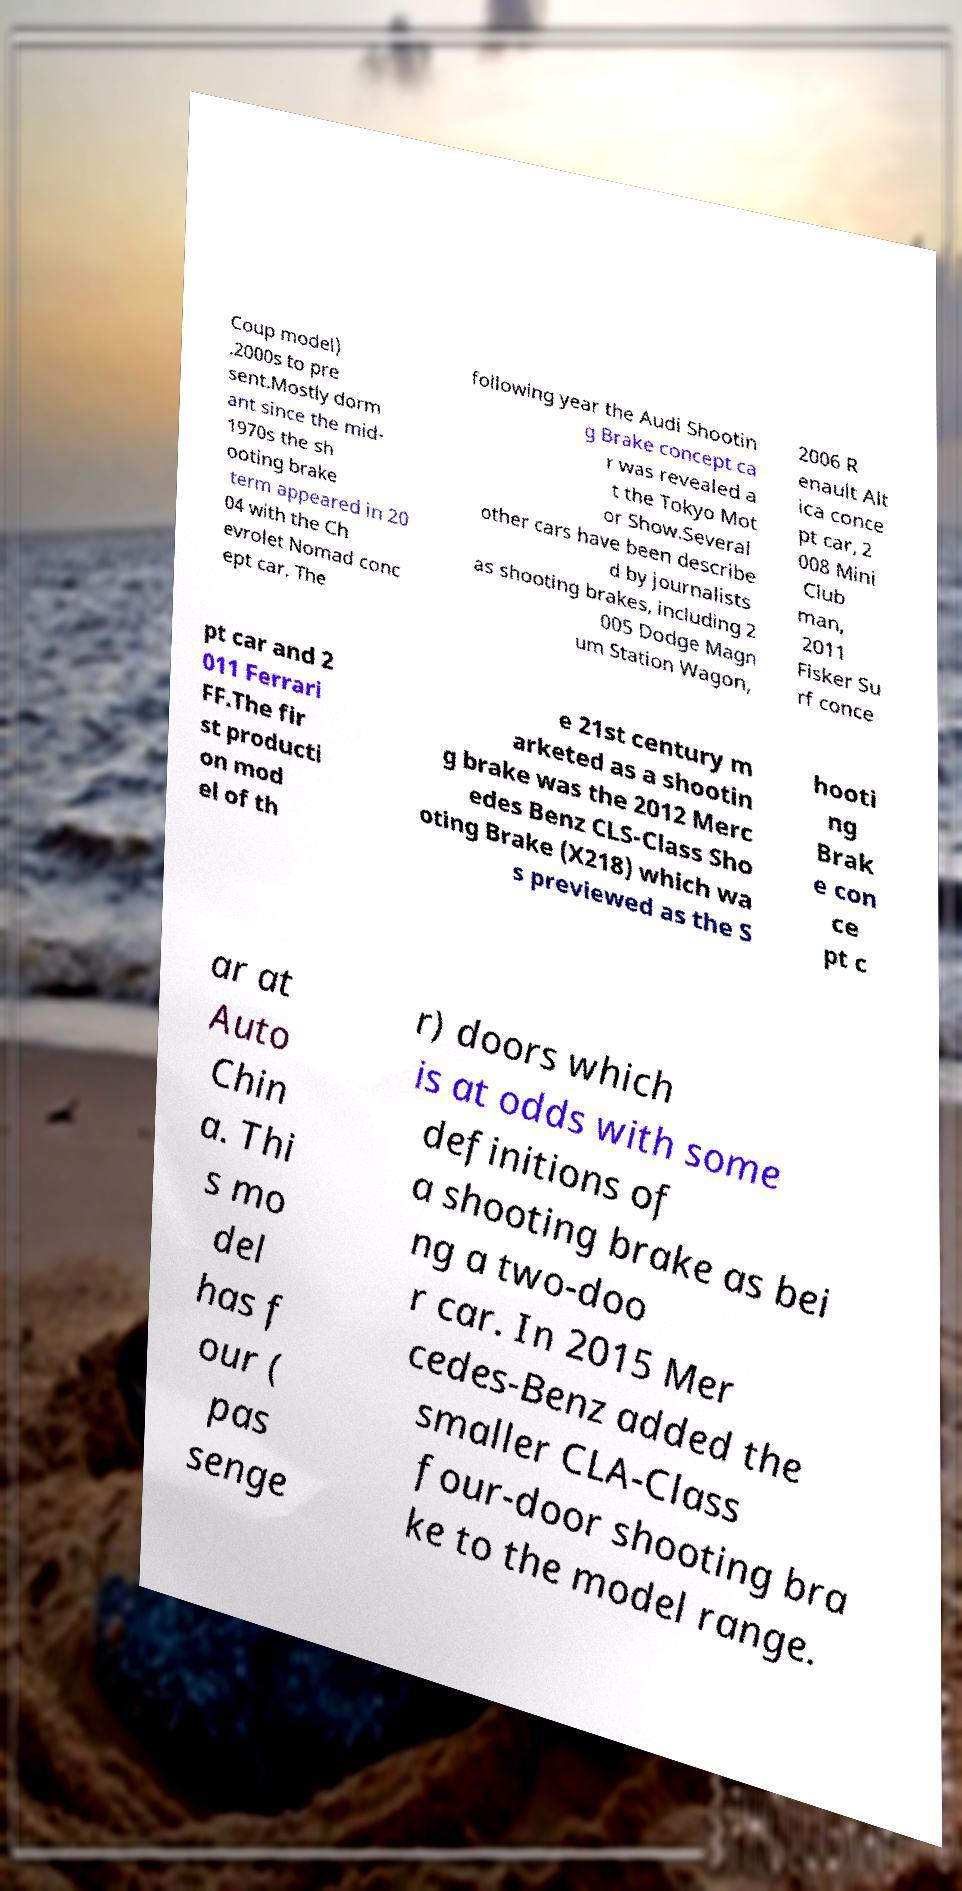Please read and relay the text visible in this image. What does it say? Coup model) .2000s to pre sent.Mostly dorm ant since the mid- 1970s the sh ooting brake term appeared in 20 04 with the Ch evrolet Nomad conc ept car. The following year the Audi Shootin g Brake concept ca r was revealed a t the Tokyo Mot or Show.Several other cars have been describe d by journalists as shooting brakes, including 2 005 Dodge Magn um Station Wagon, 2006 R enault Alt ica conce pt car, 2 008 Mini Club man, 2011 Fisker Su rf conce pt car and 2 011 Ferrari FF.The fir st producti on mod el of th e 21st century m arketed as a shootin g brake was the 2012 Merc edes Benz CLS-Class Sho oting Brake (X218) which wa s previewed as the S hooti ng Brak e con ce pt c ar at Auto Chin a. Thi s mo del has f our ( pas senge r) doors which is at odds with some definitions of a shooting brake as bei ng a two-doo r car. In 2015 Mer cedes-Benz added the smaller CLA-Class four-door shooting bra ke to the model range. 